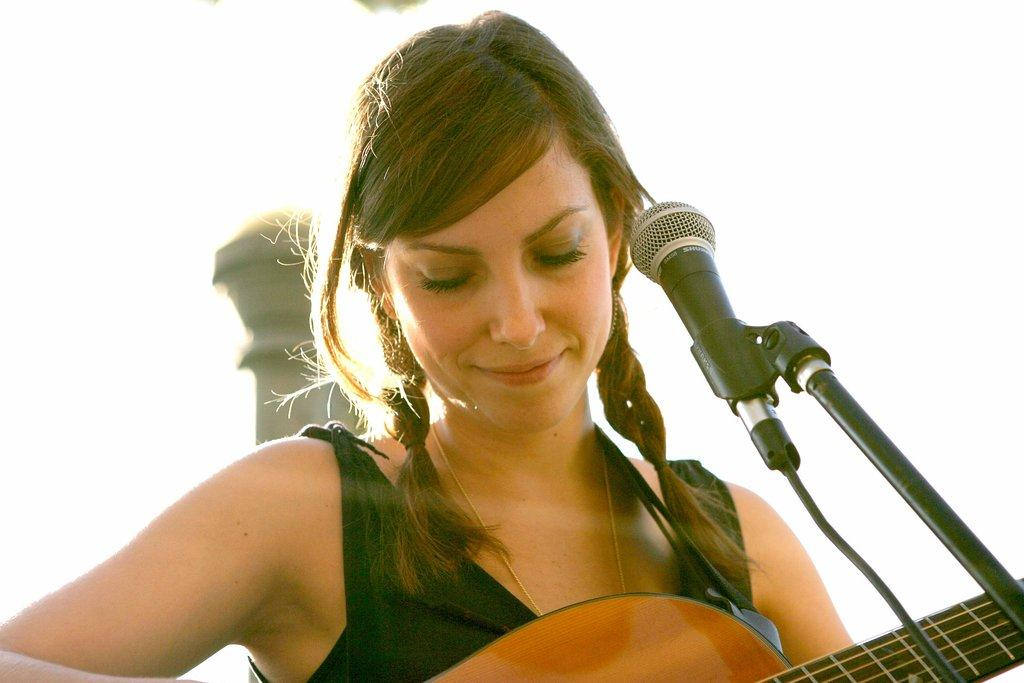Who is the main subject in the image? There is a woman in the image. What is the woman doing in the image? The woman is playing a guitar and smiling. What object is present that is typically used for amplifying sound? There is a microphone in the image. What celestial body can be seen in the image? The Earth is visible in the image. What type of carriage is being pulled by horses in the image? There is no carriage or horses present in the image. Is the woman wearing a veil in the image? No, the woman is not wearing a veil in the image. 